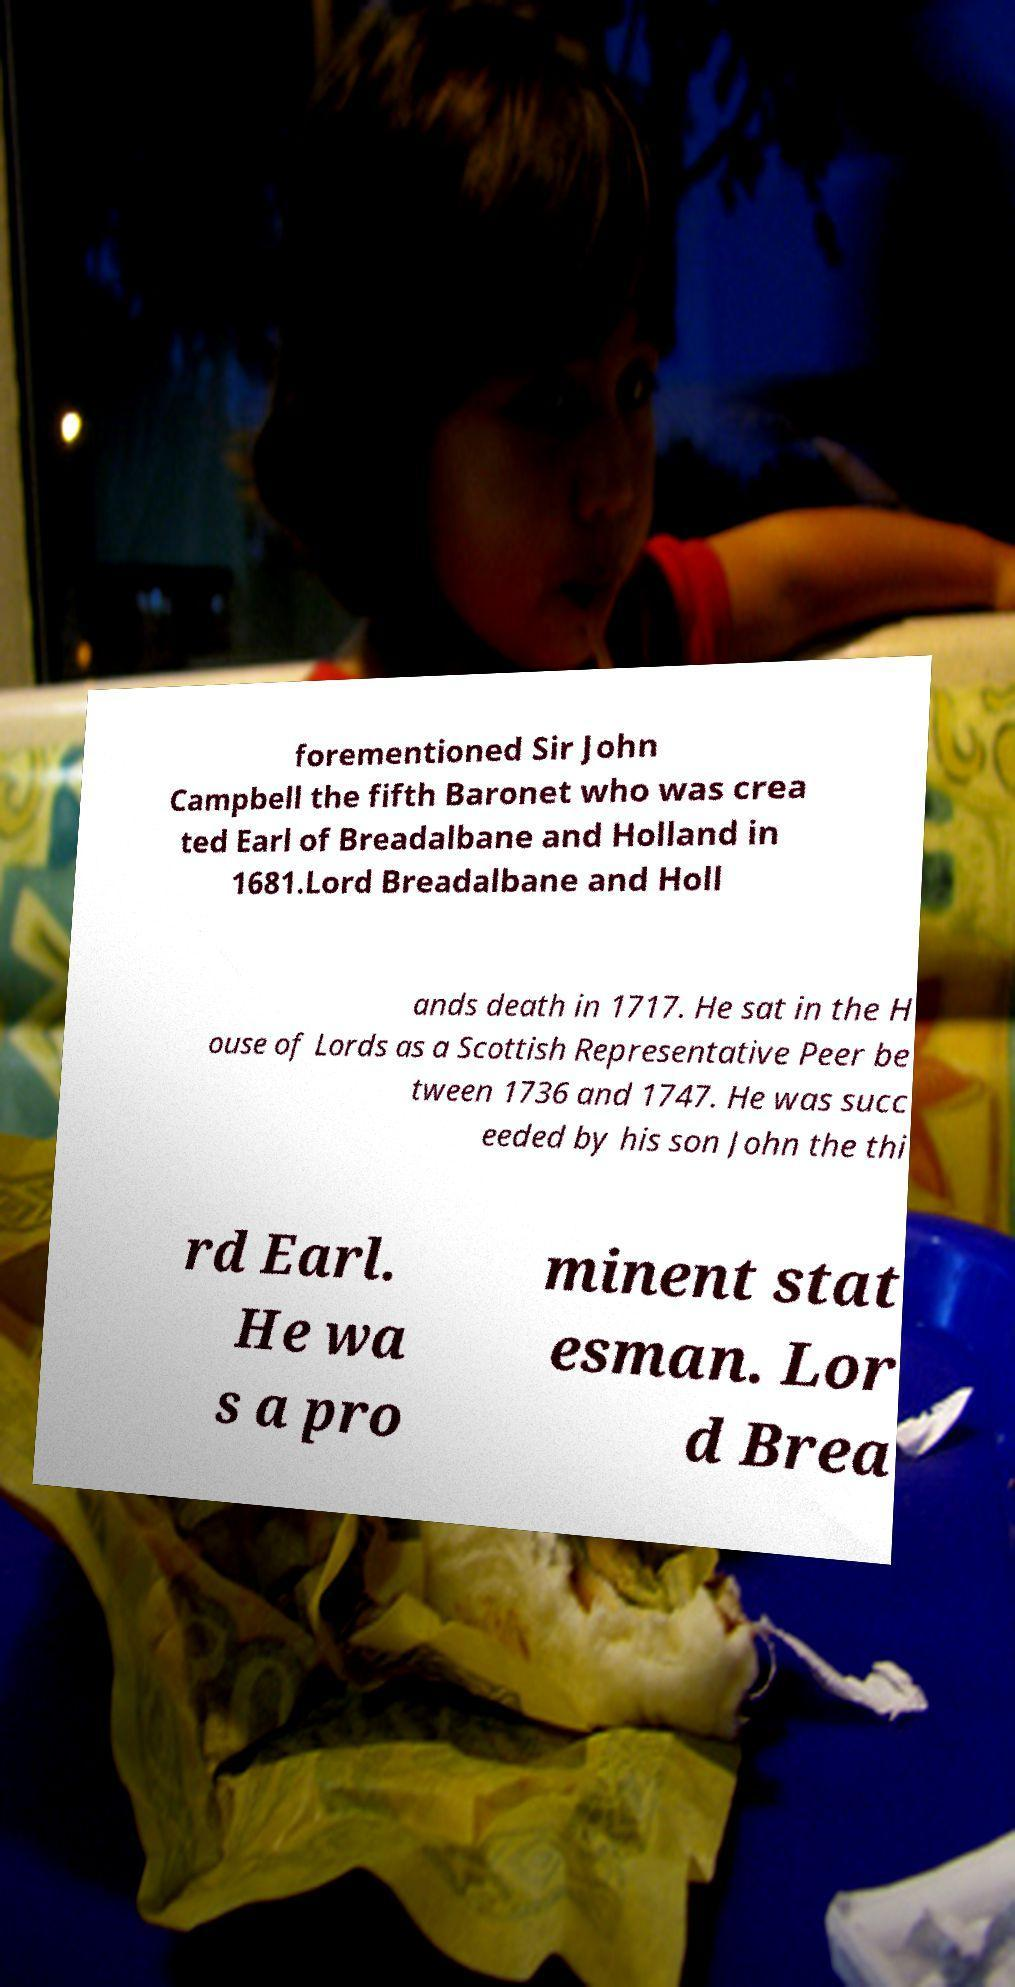Please read and relay the text visible in this image. What does it say? forementioned Sir John Campbell the fifth Baronet who was crea ted Earl of Breadalbane and Holland in 1681.Lord Breadalbane and Holl ands death in 1717. He sat in the H ouse of Lords as a Scottish Representative Peer be tween 1736 and 1747. He was succ eeded by his son John the thi rd Earl. He wa s a pro minent stat esman. Lor d Brea 